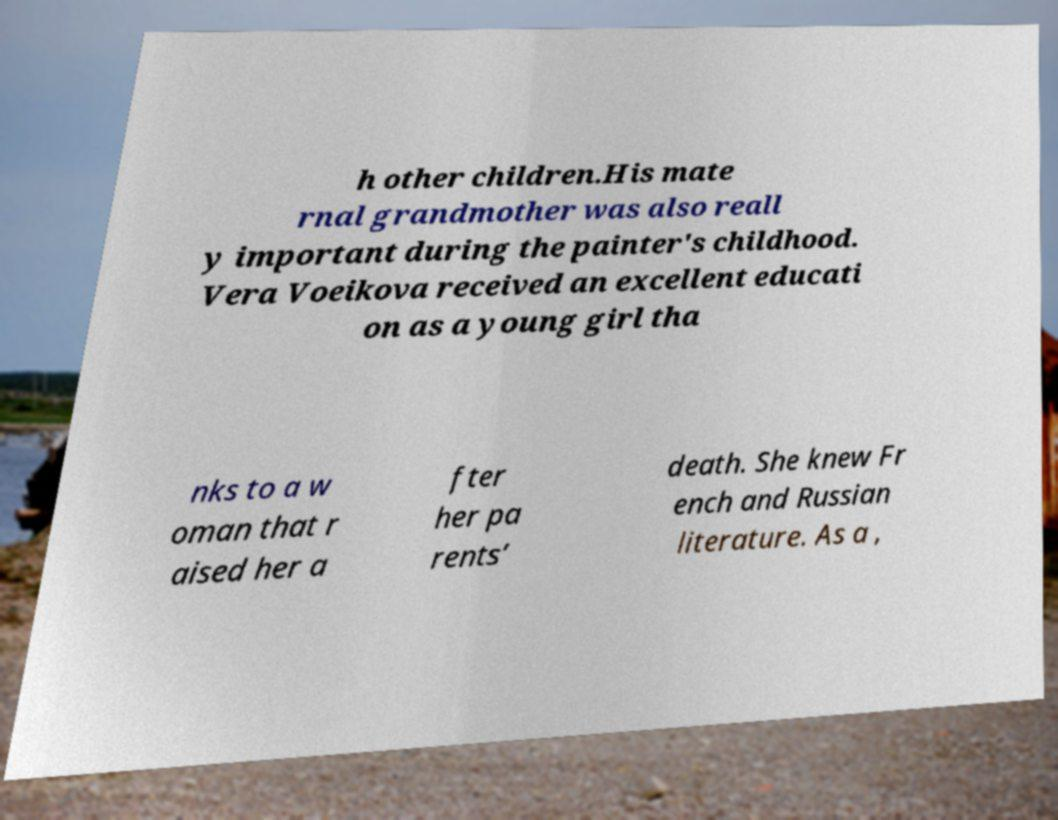Please identify and transcribe the text found in this image. h other children.His mate rnal grandmother was also reall y important during the painter's childhood. Vera Voeikova received an excellent educati on as a young girl tha nks to a w oman that r aised her a fter her pa rents’ death. She knew Fr ench and Russian literature. As a , 